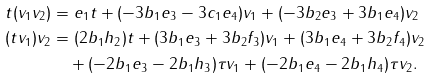<formula> <loc_0><loc_0><loc_500><loc_500>t ( v _ { 1 } v _ { 2 } ) & = e _ { 1 } t + ( - 3 b _ { 1 } e _ { 3 } - 3 c _ { 1 } e _ { 4 } ) v _ { 1 } + ( - 3 b _ { 2 } e _ { 3 } + 3 b _ { 1 } e _ { 4 } ) v _ { 2 } \\ ( t v _ { 1 } ) v _ { 2 } & = ( 2 b _ { 1 } h _ { 2 } ) t + ( 3 b _ { 1 } e _ { 3 } + 3 b _ { 2 } f _ { 3 } ) v _ { 1 } + ( 3 b _ { 1 } e _ { 4 } + 3 b _ { 2 } f _ { 4 } ) v _ { 2 } \\ & \quad + ( - 2 b _ { 1 } e _ { 3 } - 2 b _ { 1 } h _ { 3 } ) \tau v _ { 1 } + ( - 2 b _ { 1 } e _ { 4 } - 2 b _ { 1 } h _ { 4 } ) \tau v _ { 2 } .</formula> 